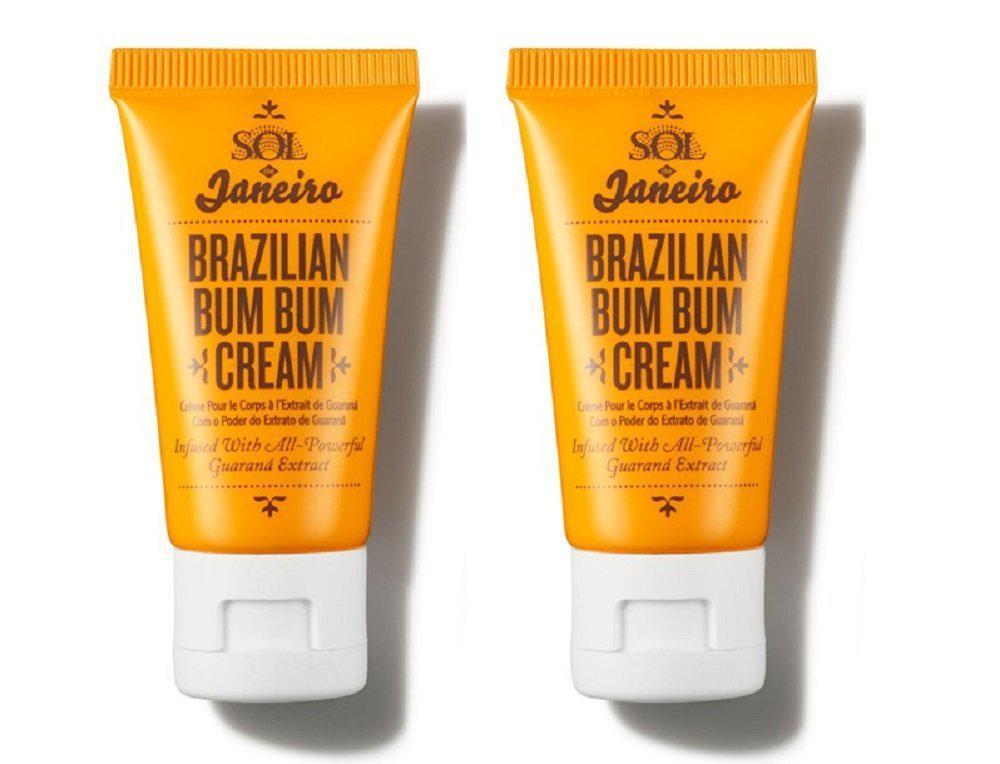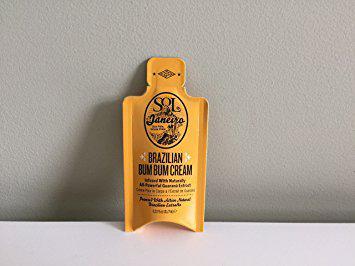The first image is the image on the left, the second image is the image on the right. For the images displayed, is the sentence "One of the images contains only a single orange squeeze tube with a white cap." factually correct? Answer yes or no. No. The first image is the image on the left, the second image is the image on the right. Given the left and right images, does the statement "The left image contains one yellow tube with a flat white cap, and the right image includes a product with a yellow bowl-shaped bottom and a flat-topped white lid with black print around it." hold true? Answer yes or no. No. 